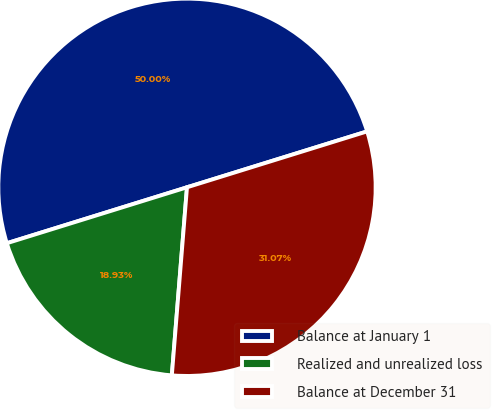Convert chart to OTSL. <chart><loc_0><loc_0><loc_500><loc_500><pie_chart><fcel>Balance at January 1<fcel>Realized and unrealized loss<fcel>Balance at December 31<nl><fcel>50.0%<fcel>18.93%<fcel>31.07%<nl></chart> 